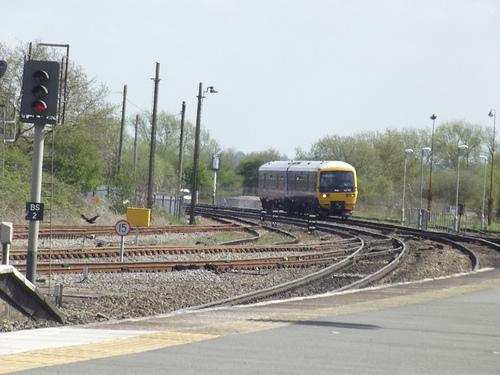Question: how many traffic signals are there?
Choices:
A. 2.
B. 3.
C. 1.
D. 6.
Answer with the letter. Answer: C Question: who drives the train?
Choices:
A. Engine.
B. Caboose.
C. Steam.
D. Conductor.
Answer with the letter. Answer: D Question: how many sets of tracks are there?
Choices:
A. 1.
B. 2.
C. 5.
D. 3.
Answer with the letter. Answer: C Question: how many cars on the train?
Choices:
A. 1.
B. 3.
C. 6.
D. 2.
Answer with the letter. Answer: D 